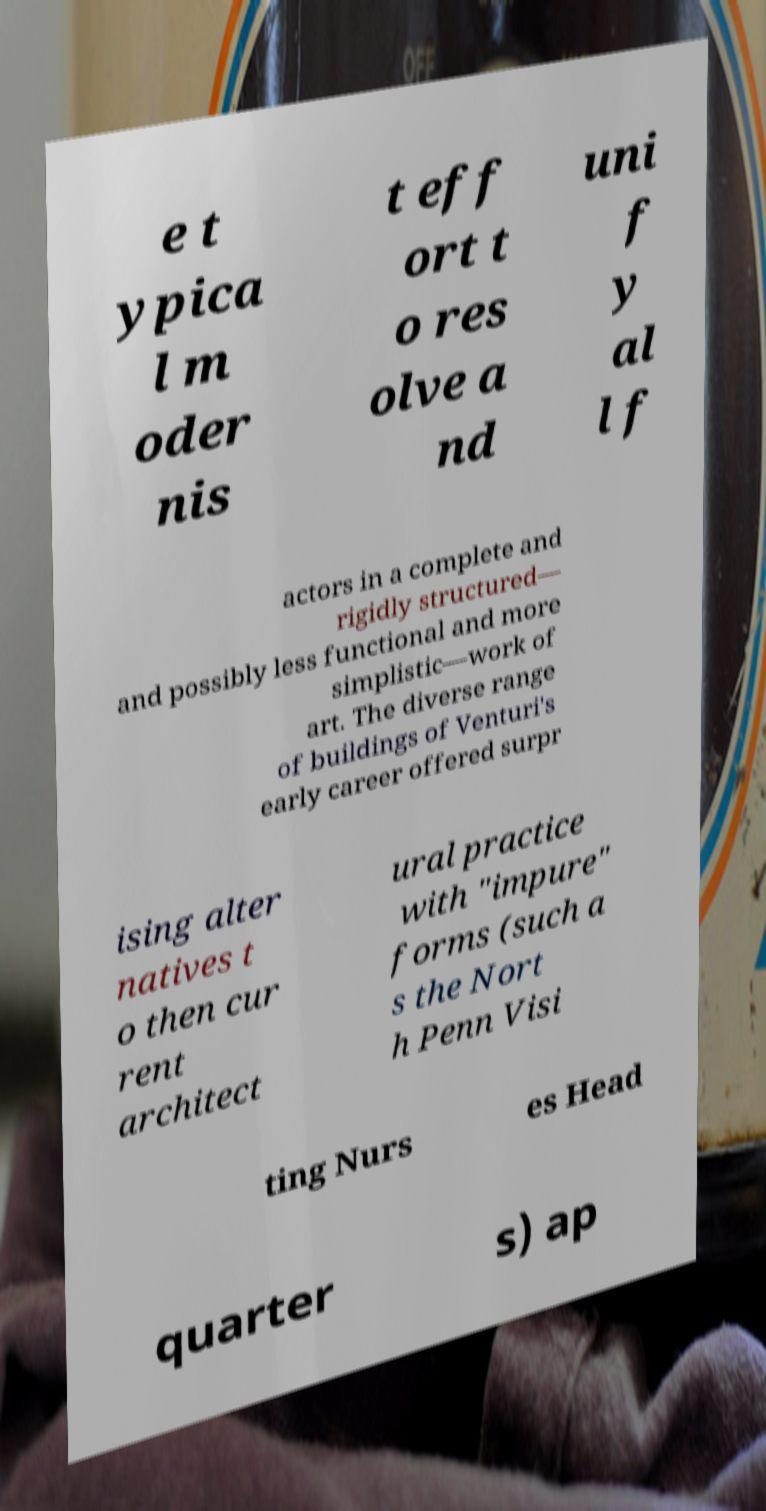Can you accurately transcribe the text from the provided image for me? e t ypica l m oder nis t eff ort t o res olve a nd uni f y al l f actors in a complete and rigidly structured— and possibly less functional and more simplistic—work of art. The diverse range of buildings of Venturi's early career offered surpr ising alter natives t o then cur rent architect ural practice with "impure" forms (such a s the Nort h Penn Visi ting Nurs es Head quarter s) ap 